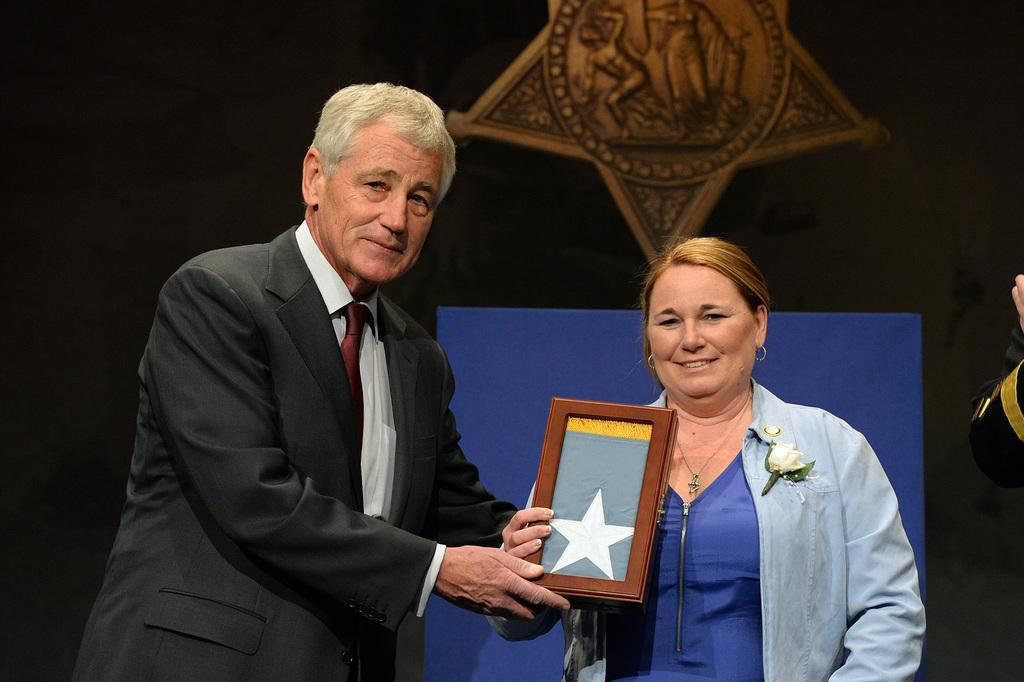In one or two sentences, can you explain what this image depicts? In the center of the image there is a person wearing a black color suit. Beside him there is a lady wearing denim jacket. The background of the image is black. 